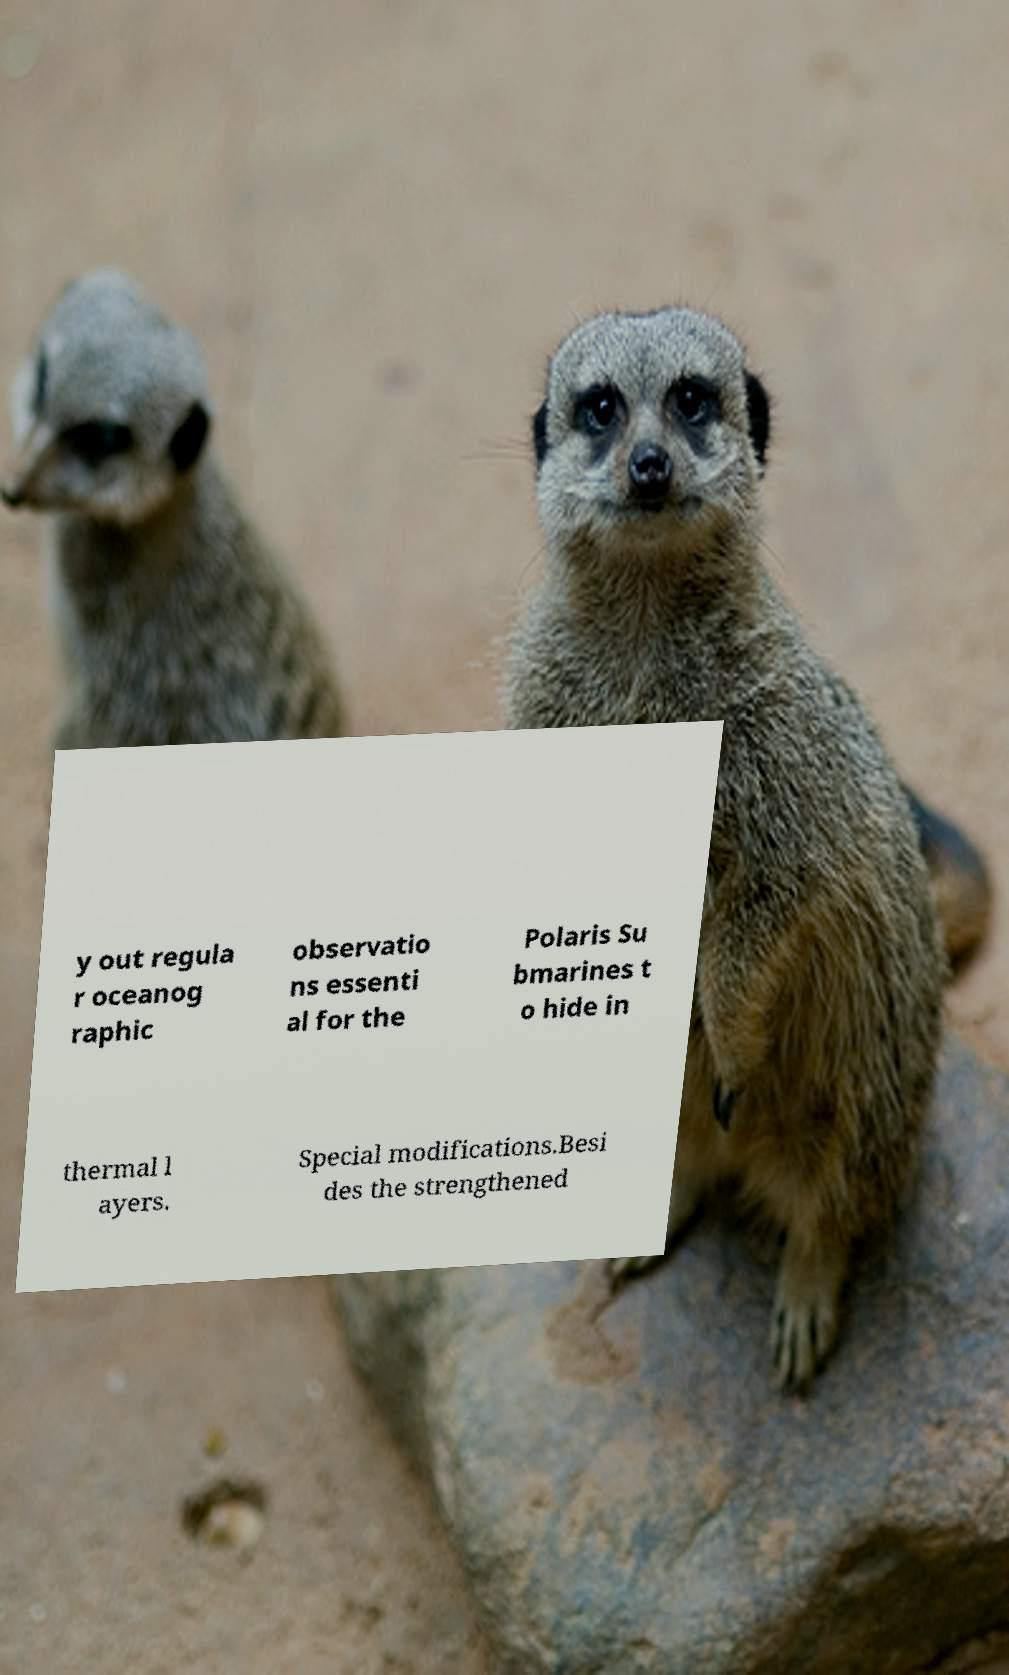Could you extract and type out the text from this image? y out regula r oceanog raphic observatio ns essenti al for the Polaris Su bmarines t o hide in thermal l ayers. Special modifications.Besi des the strengthened 